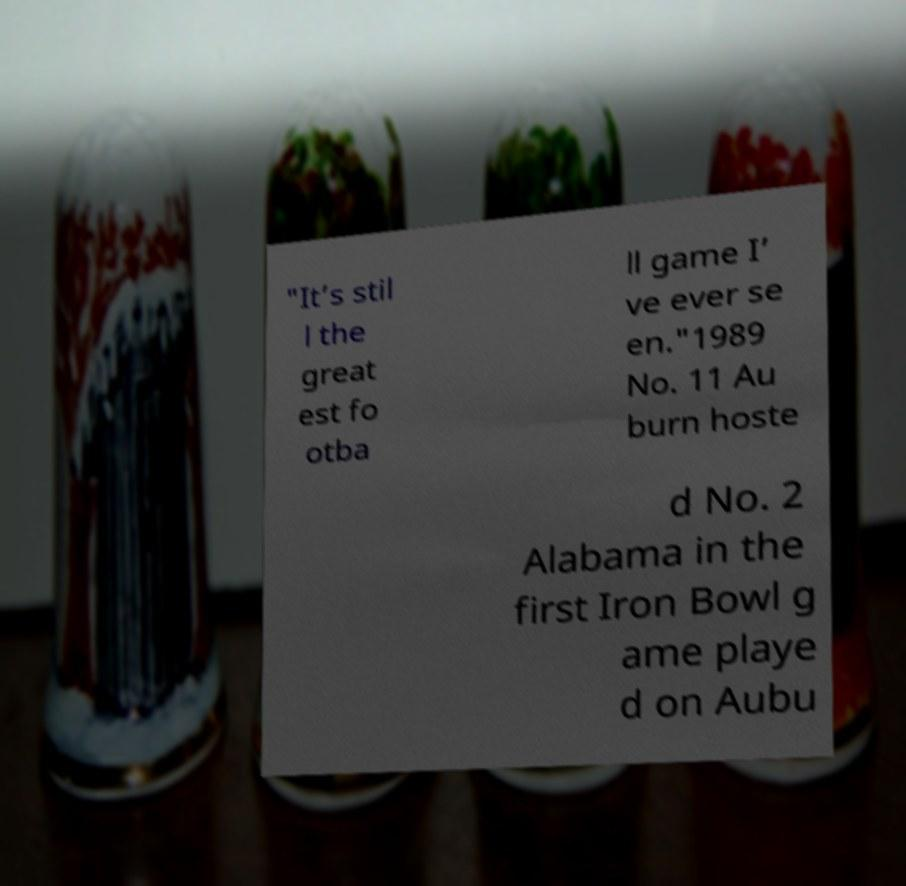Please identify and transcribe the text found in this image. "It’s stil l the great est fo otba ll game I’ ve ever se en."1989 No. 11 Au burn hoste d No. 2 Alabama in the first Iron Bowl g ame playe d on Aubu 